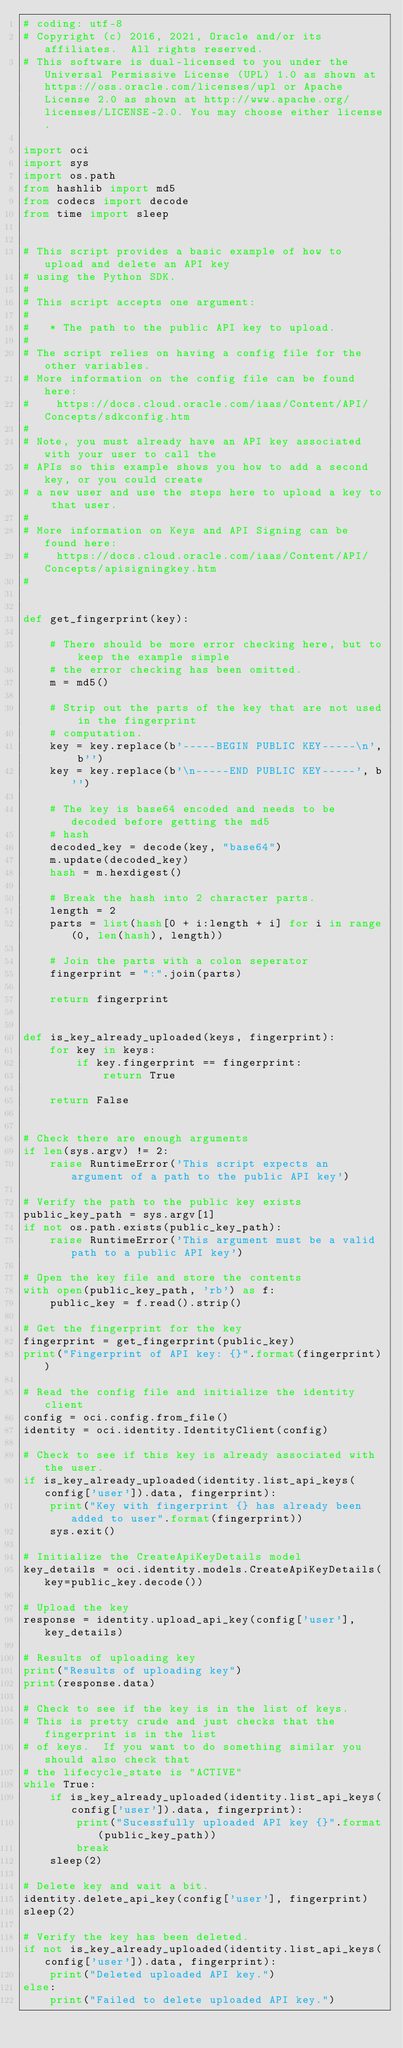<code> <loc_0><loc_0><loc_500><loc_500><_Python_># coding: utf-8
# Copyright (c) 2016, 2021, Oracle and/or its affiliates.  All rights reserved.
# This software is dual-licensed to you under the Universal Permissive License (UPL) 1.0 as shown at https://oss.oracle.com/licenses/upl or Apache License 2.0 as shown at http://www.apache.org/licenses/LICENSE-2.0. You may choose either license.

import oci
import sys
import os.path
from hashlib import md5
from codecs import decode
from time import sleep


# This script provides a basic example of how to upload and delete an API key
# using the Python SDK.
#
# This script accepts one argument:
#
#   * The path to the public API key to upload.
#
# The script relies on having a config file for the other variables.
# More information on the config file can be found here:
#    https://docs.cloud.oracle.com/iaas/Content/API/Concepts/sdkconfig.htm
#
# Note, you must already have an API key associated with your user to call the
# APIs so this example shows you how to add a second key, or you could create
# a new user and use the steps here to upload a key to that user.
#
# More information on Keys and API Signing can be found here:
#    https://docs.cloud.oracle.com/iaas/Content/API/Concepts/apisigningkey.htm
#


def get_fingerprint(key):

    # There should be more error checking here, but to keep the example simple
    # the error checking has been omitted.
    m = md5()

    # Strip out the parts of the key that are not used in the fingerprint
    # computation.
    key = key.replace(b'-----BEGIN PUBLIC KEY-----\n', b'')
    key = key.replace(b'\n-----END PUBLIC KEY-----', b'')

    # The key is base64 encoded and needs to be decoded before getting the md5
    # hash
    decoded_key = decode(key, "base64")
    m.update(decoded_key)
    hash = m.hexdigest()

    # Break the hash into 2 character parts.
    length = 2
    parts = list(hash[0 + i:length + i] for i in range(0, len(hash), length))

    # Join the parts with a colon seperator
    fingerprint = ":".join(parts)

    return fingerprint


def is_key_already_uploaded(keys, fingerprint):
    for key in keys:
        if key.fingerprint == fingerprint:
            return True

    return False


# Check there are enough arguments
if len(sys.argv) != 2:
    raise RuntimeError('This script expects an argument of a path to the public API key')

# Verify the path to the public key exists
public_key_path = sys.argv[1]
if not os.path.exists(public_key_path):
    raise RuntimeError('This argument must be a valid path to a public API key')

# Open the key file and store the contents
with open(public_key_path, 'rb') as f:
    public_key = f.read().strip()

# Get the fingerprint for the key
fingerprint = get_fingerprint(public_key)
print("Fingerprint of API key: {}".format(fingerprint))

# Read the config file and initialize the identity client
config = oci.config.from_file()
identity = oci.identity.IdentityClient(config)

# Check to see if this key is already associated with the user.
if is_key_already_uploaded(identity.list_api_keys(config['user']).data, fingerprint):
    print("Key with fingerprint {} has already been added to user".format(fingerprint))
    sys.exit()

# Initialize the CreateApiKeyDetails model
key_details = oci.identity.models.CreateApiKeyDetails(key=public_key.decode())

# Upload the key
response = identity.upload_api_key(config['user'], key_details)

# Results of uploading key
print("Results of uploading key")
print(response.data)

# Check to see if the key is in the list of keys.
# This is pretty crude and just checks that the fingerprint is in the list
# of keys.  If you want to do something similar you should also check that
# the lifecycle_state is "ACTIVE"
while True:
    if is_key_already_uploaded(identity.list_api_keys(config['user']).data, fingerprint):
        print("Sucessfully uploaded API key {}".format(public_key_path))
        break
    sleep(2)

# Delete key and wait a bit.
identity.delete_api_key(config['user'], fingerprint)
sleep(2)

# Verify the key has been deleted.
if not is_key_already_uploaded(identity.list_api_keys(config['user']).data, fingerprint):
    print("Deleted uploaded API key.")
else:
    print("Failed to delete uploaded API key.")
</code> 